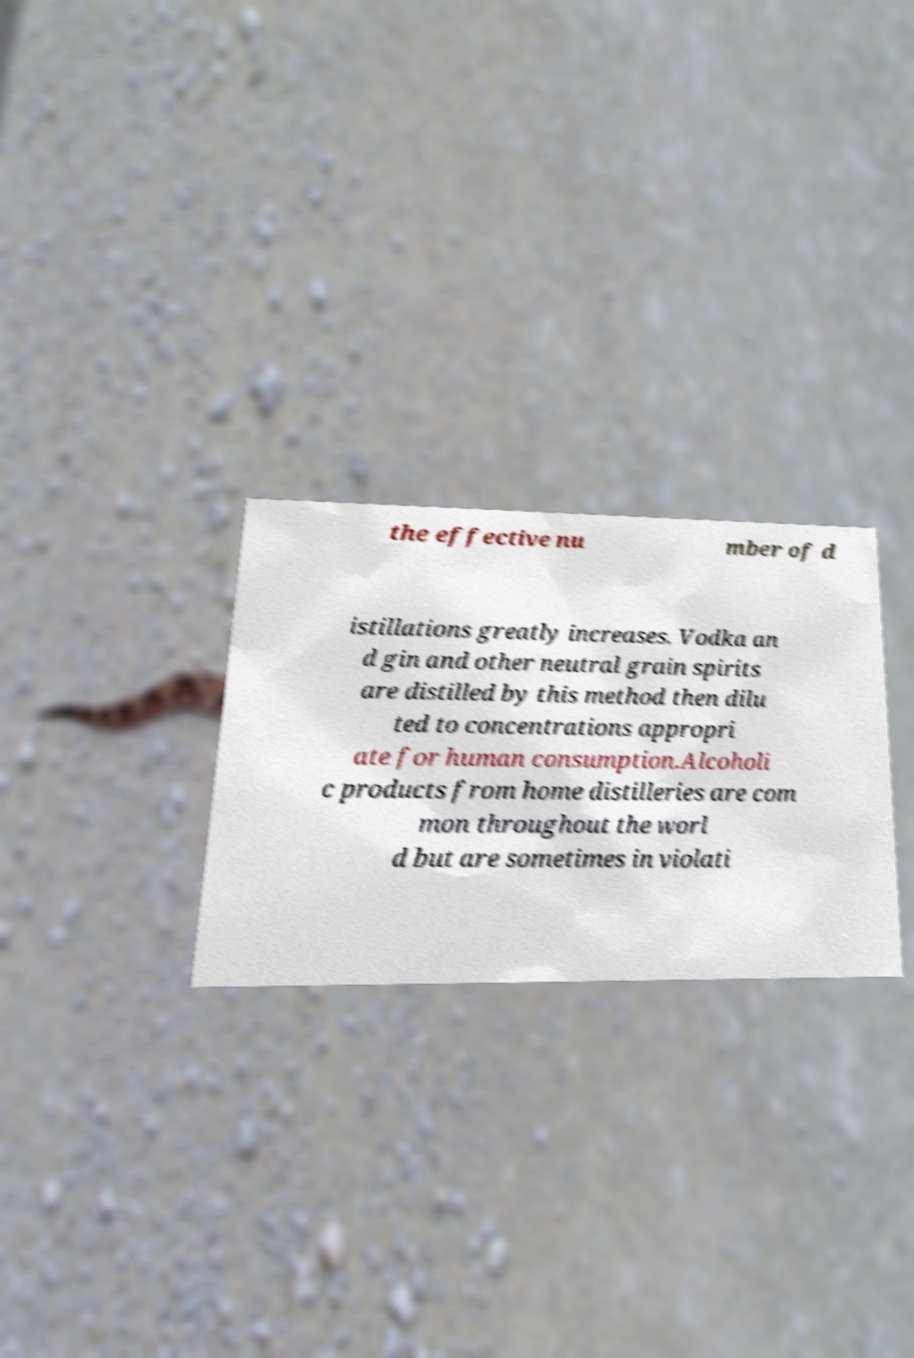Could you assist in decoding the text presented in this image and type it out clearly? the effective nu mber of d istillations greatly increases. Vodka an d gin and other neutral grain spirits are distilled by this method then dilu ted to concentrations appropri ate for human consumption.Alcoholi c products from home distilleries are com mon throughout the worl d but are sometimes in violati 